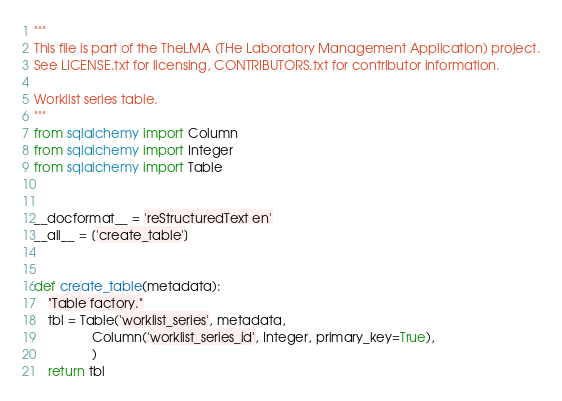<code> <loc_0><loc_0><loc_500><loc_500><_Python_>"""
This file is part of the TheLMA (THe Laboratory Management Application) project.
See LICENSE.txt for licensing, CONTRIBUTORS.txt for contributor information.

Worklist series table.
"""
from sqlalchemy import Column
from sqlalchemy import Integer
from sqlalchemy import Table


__docformat__ = 'reStructuredText en'
__all__ = ['create_table']


def create_table(metadata):
    "Table factory."
    tbl = Table('worklist_series', metadata,
                Column('worklist_series_id', Integer, primary_key=True),
                )
    return tbl
</code> 